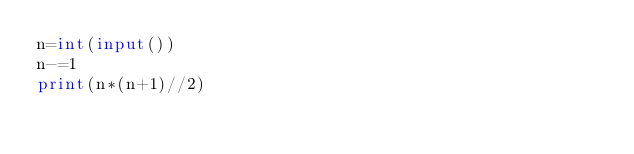<code> <loc_0><loc_0><loc_500><loc_500><_Python_>n=int(input())
n-=1
print(n*(n+1)//2)</code> 